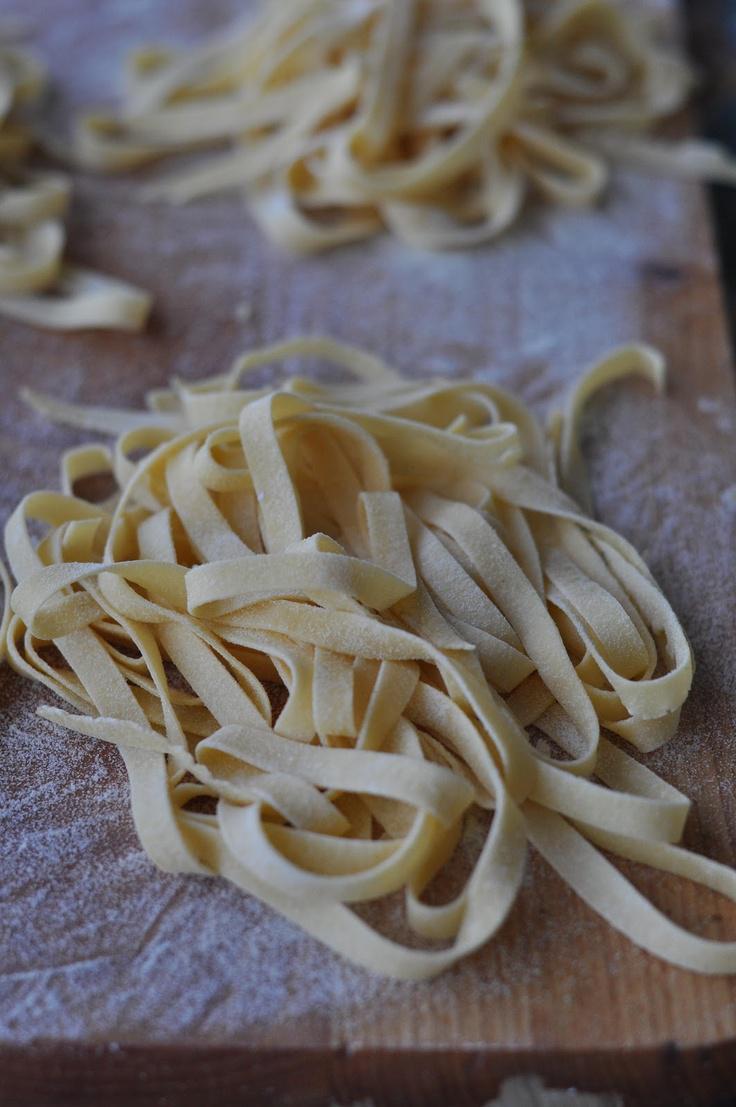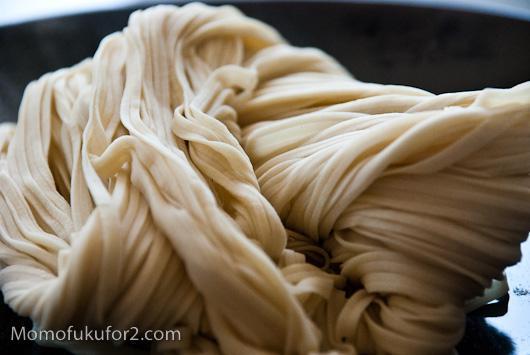The first image is the image on the left, the second image is the image on the right. Evaluate the accuracy of this statement regarding the images: "The pasta in the image on the left is sitting atop a dusting of flour.". Is it true? Answer yes or no. Yes. The first image is the image on the left, the second image is the image on the right. Evaluate the accuracy of this statement regarding the images: "There are at least 10 flat handmade noodles sitting on a wood table.". Is it true? Answer yes or no. Yes. 